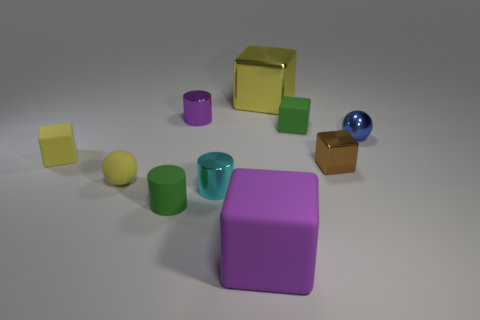What can you infer about the lighting in this scene? The scene is lit from above, as indicated by the soft shadows cast directly under each object. The lighting appears diffused, without harsh contrasts, suggesting an indoor setup with well-distributed ambient light, possibly intended to minimize distracting shadows and highlight the colors and shapes of the objects. 